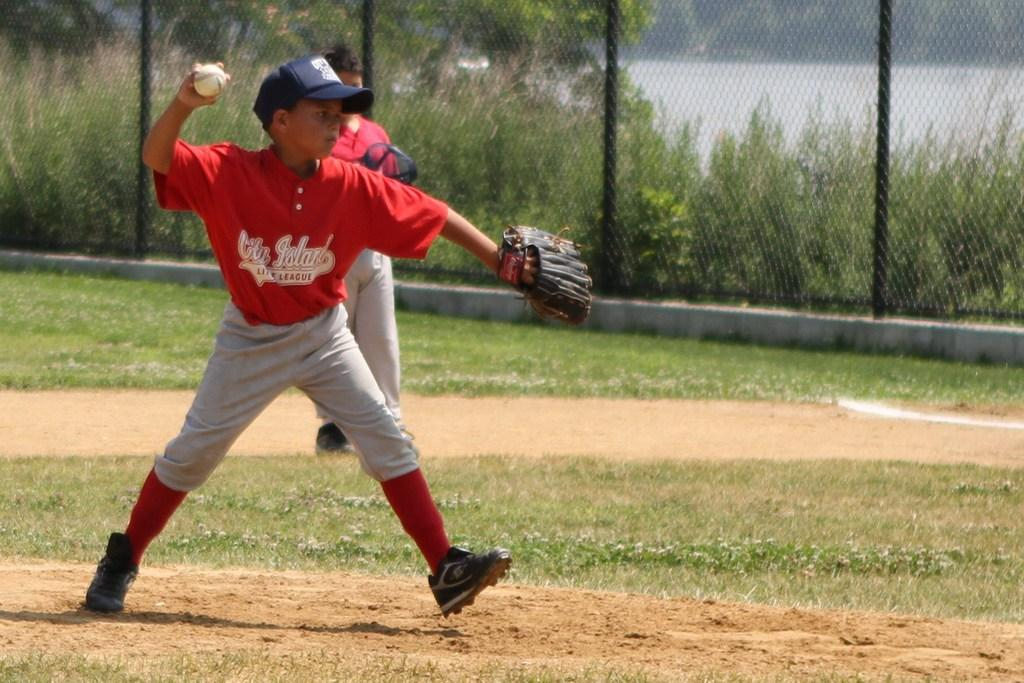<image>
Share a concise interpretation of the image provided. A boy for the City Island team about to throw a baseball. 